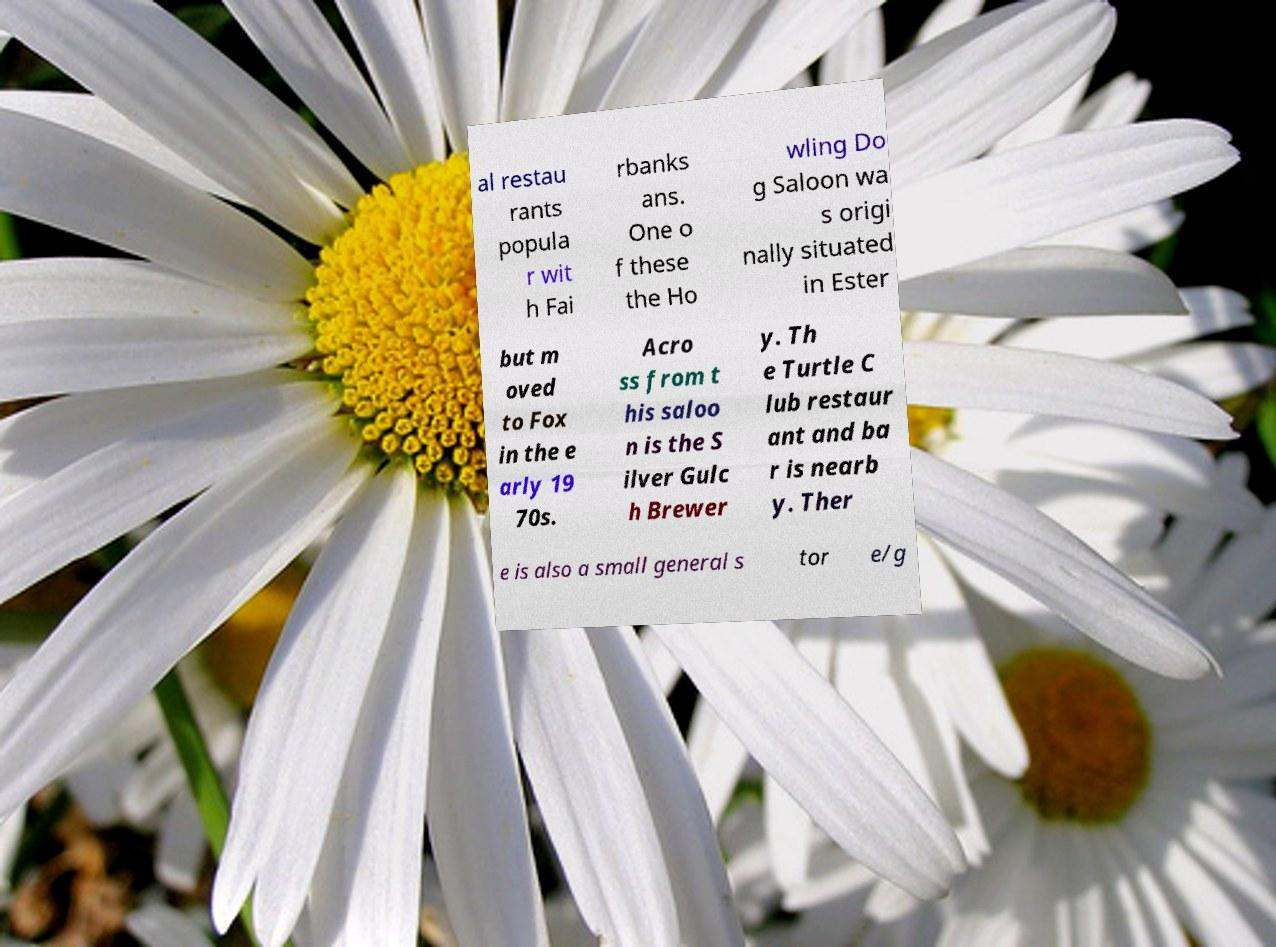For documentation purposes, I need the text within this image transcribed. Could you provide that? al restau rants popula r wit h Fai rbanks ans. One o f these the Ho wling Do g Saloon wa s origi nally situated in Ester but m oved to Fox in the e arly 19 70s. Acro ss from t his saloo n is the S ilver Gulc h Brewer y. Th e Turtle C lub restaur ant and ba r is nearb y. Ther e is also a small general s tor e/g 